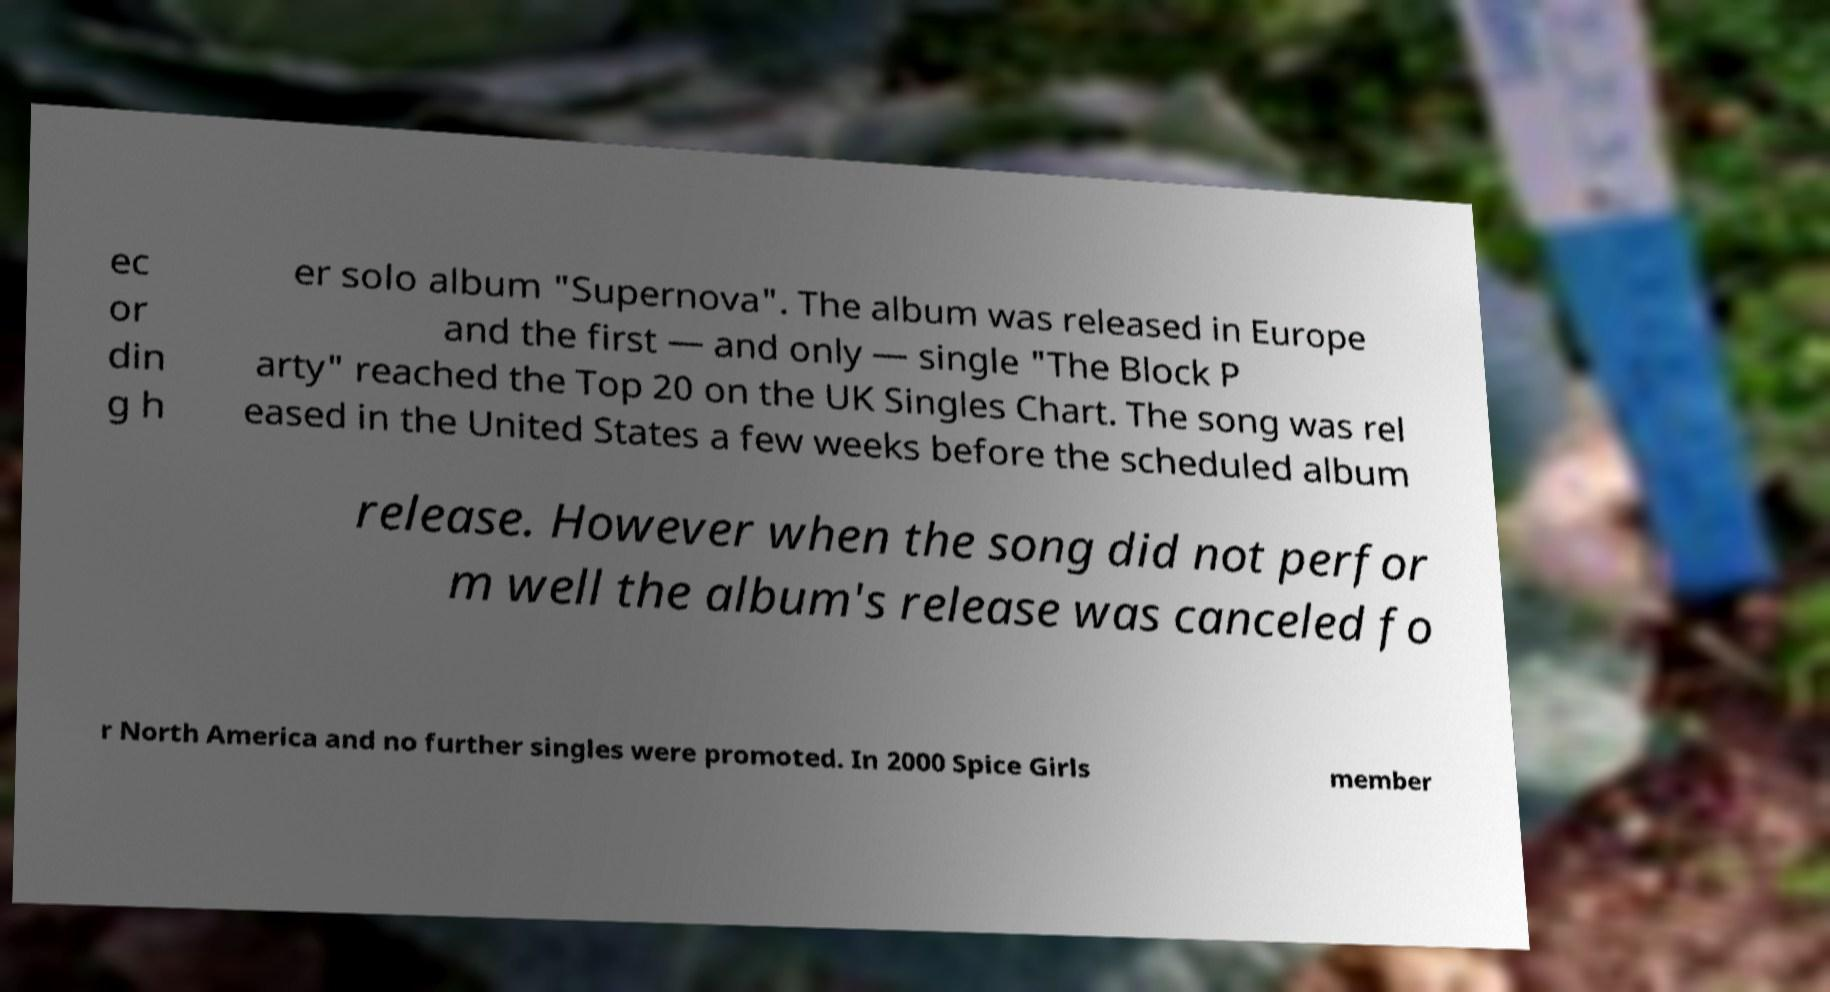Could you assist in decoding the text presented in this image and type it out clearly? ec or din g h er solo album "Supernova". The album was released in Europe and the first — and only — single "The Block P arty" reached the Top 20 on the UK Singles Chart. The song was rel eased in the United States a few weeks before the scheduled album release. However when the song did not perfor m well the album's release was canceled fo r North America and no further singles were promoted. In 2000 Spice Girls member 